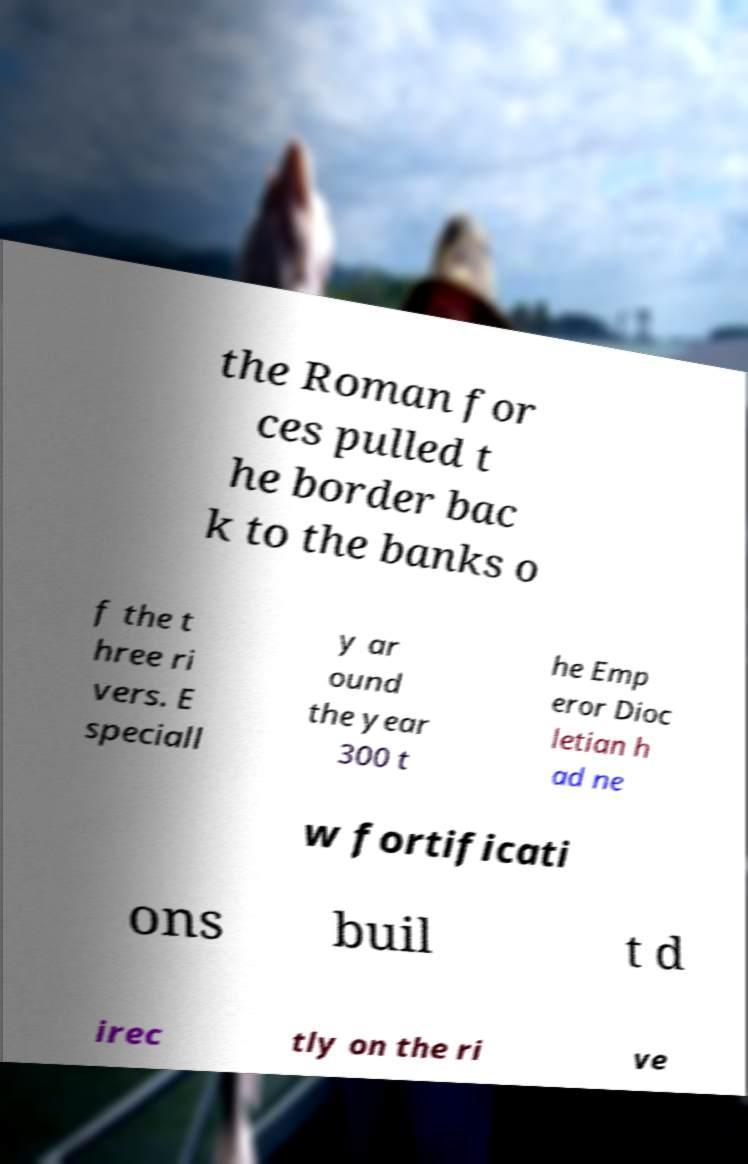What messages or text are displayed in this image? I need them in a readable, typed format. the Roman for ces pulled t he border bac k to the banks o f the t hree ri vers. E speciall y ar ound the year 300 t he Emp eror Dioc letian h ad ne w fortificati ons buil t d irec tly on the ri ve 